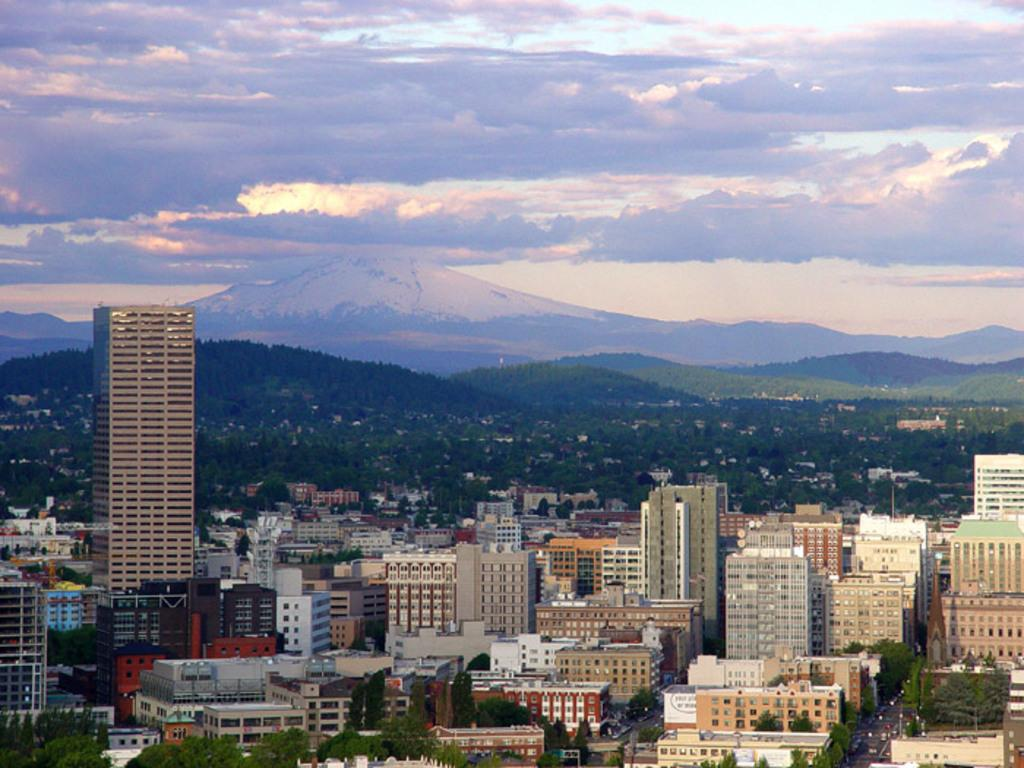What types of structures can be seen in the image? There are multiple buildings in the image. What type of natural elements are present in the image? There are multiple trees and mountains visible in the image. What can be seen in the background of the image? Clouds and the sky are present in the background of the image. How many rings are visible on the trees in the image? There are no rings visible on the trees in the image, as rings are not a visible feature of trees in photographs. 